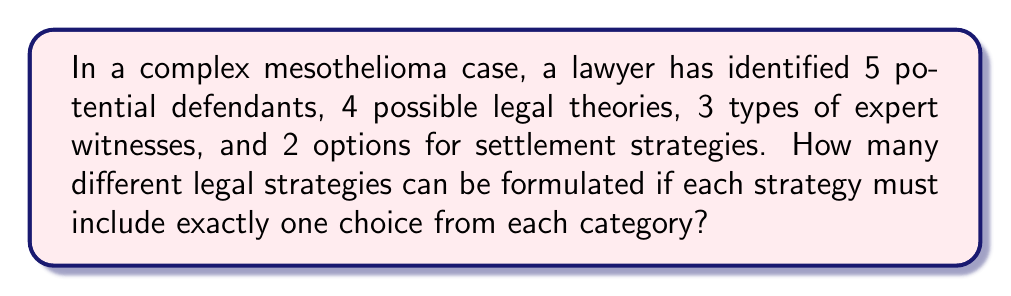Show me your answer to this math problem. To solve this problem, we'll use the multiplication principle of counting. This principle states that if we have a sequence of independent choices, the total number of possible outcomes is the product of the number of options for each choice.

Let's break down the problem:

1. Number of potential defendants: 5
2. Number of possible legal theories: 4
3. Number of types of expert witnesses: 3
4. Number of settlement strategy options: 2

Each legal strategy must include one choice from each category. This means we're making four independent choices, one after the other:

1. Choose 1 defendant out of 5
2. Choose 1 legal theory out of 4
3. Choose 1 type of expert witness out of 3
4. Choose 1 settlement strategy out of 2

According to the multiplication principle, we multiply these numbers:

$$ 5 \times 4 \times 3 \times 2 = 120 $$

Therefore, the total number of potential legal strategies is 120.
Answer: 120 